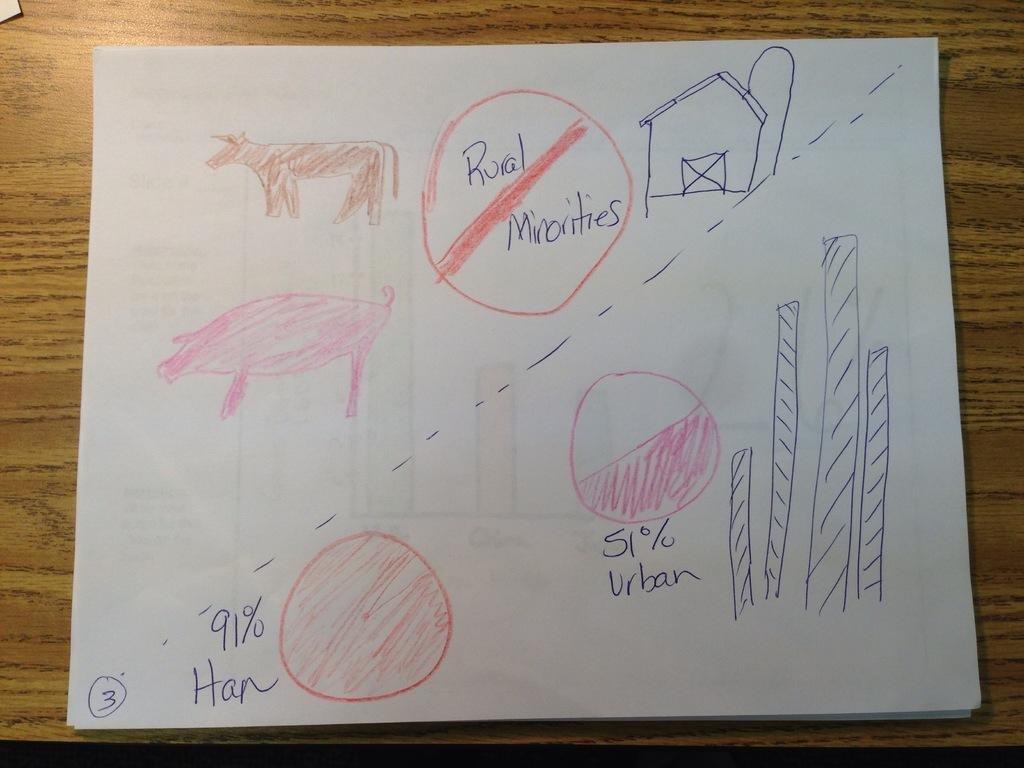What is the main subject in the center of the image? There is a paper in the center of the image. Where is the paper located? The paper is placed on a table. What can be seen on the paper? There are drawings and text on the paper. How many oranges are hanging from the hook in the image? There is no hook or oranges present in the image. What type of box is visible on the paper? There is no box visible on the paper; it only contains drawings and text. 